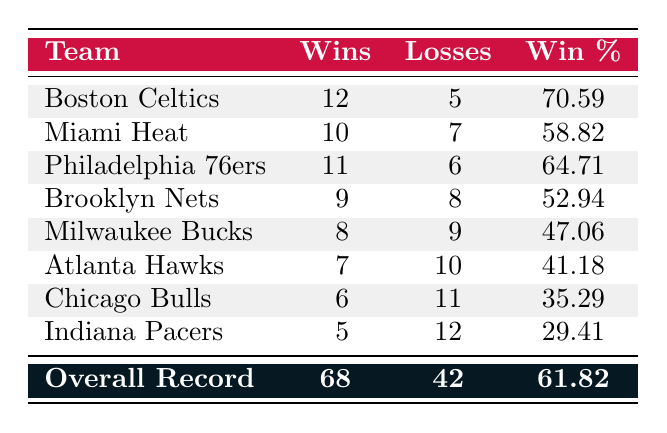What is the Raptors' win-loss record against the Boston Celtics? The table lists that the Raptors have recorded 12 wins and 5 losses against the Boston Celtics.
Answer: 12 wins, 5 losses What team did the Raptors have the worst win percentage against? Looking at the win percentages in the table, the Indiana Pacers have the lowest win percentage at 29.41%.
Answer: Indiana Pacers What is the Raptors' overall win percentage against Eastern Conference teams? The overall record shows that the Raptors have 68 wins out of 110 total games (68 wins + 42 losses). Thus, the win percentage is calculated as 68/110 = 61.82%.
Answer: 61.82% How many more wins did the Raptors have against the Miami Heat compared to the Atlanta Hawks? The Raptors have 10 wins against the Miami Heat and 7 wins against the Atlanta Hawks. When calculating the difference, 10 - 7 = 3.
Answer: 3 more wins Is it true that the Raptors won more games against the Philadelphia 76ers than the Miami Heat? The table indicates that the Raptors won 11 games against the Philadelphia 76ers compared to 10 against the Miami Heat, confirming that it is true.
Answer: Yes What is the total number of wins the Raptors have against all Eastern Conference teams combined? By summing all the wins: 12 (Celtics) + 10 (Heat) + 11 (76ers) + 9 (Nets) + 8 (Bucks) + 7 (Hawks) + 6 (Bulls) + 5 (Pacers) = 68 wins.
Answer: 68 wins Which team had a better win-loss record than the Milwaukee Bucks? The table shows that the Brooklyn Nets (9 wins, 8 losses) and Atlanta Hawks (7 wins, 10 losses) had a better record than the Milwaukee Bucks (8 wins, 9 losses), while the teams above had more wins despite Milwaukee's nominal wins.
Answer: Brooklyn Nets What is the difference in losses between the team with the most wins and the team with the fewest wins? The Boston Celtics have the most wins (12 wins, 5 losses) and the Indiana Pacers have the fewest wins (5 wins, 12 losses). To find the difference in losses: 12 (Pacers) - 5 (Celtics) = 7 losses.
Answer: 7 losses 